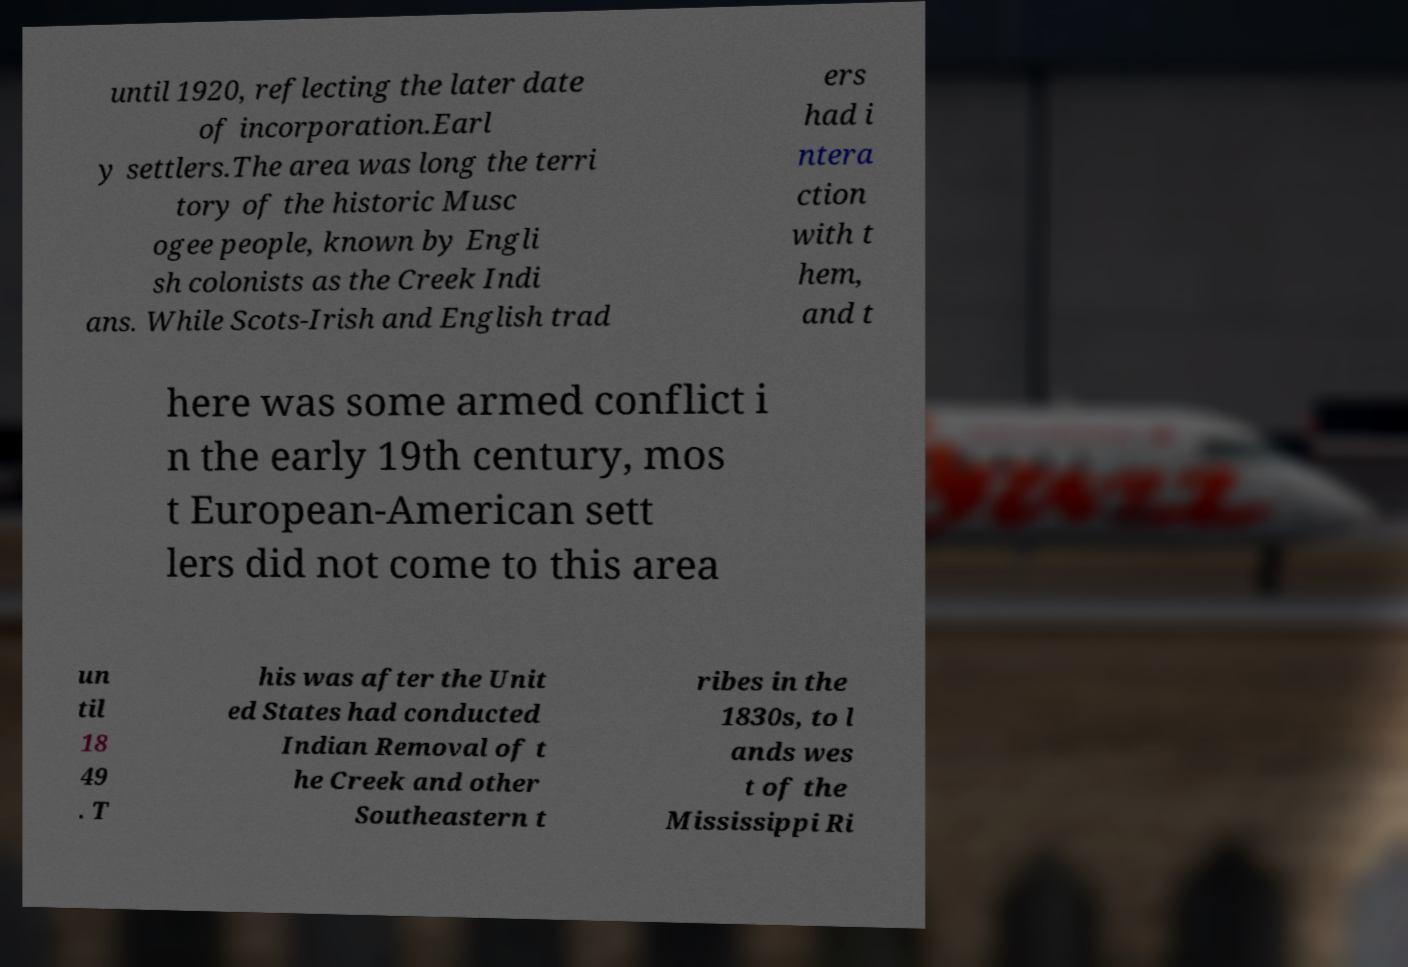Can you accurately transcribe the text from the provided image for me? until 1920, reflecting the later date of incorporation.Earl y settlers.The area was long the terri tory of the historic Musc ogee people, known by Engli sh colonists as the Creek Indi ans. While Scots-Irish and English trad ers had i ntera ction with t hem, and t here was some armed conflict i n the early 19th century, mos t European-American sett lers did not come to this area un til 18 49 . T his was after the Unit ed States had conducted Indian Removal of t he Creek and other Southeastern t ribes in the 1830s, to l ands wes t of the Mississippi Ri 